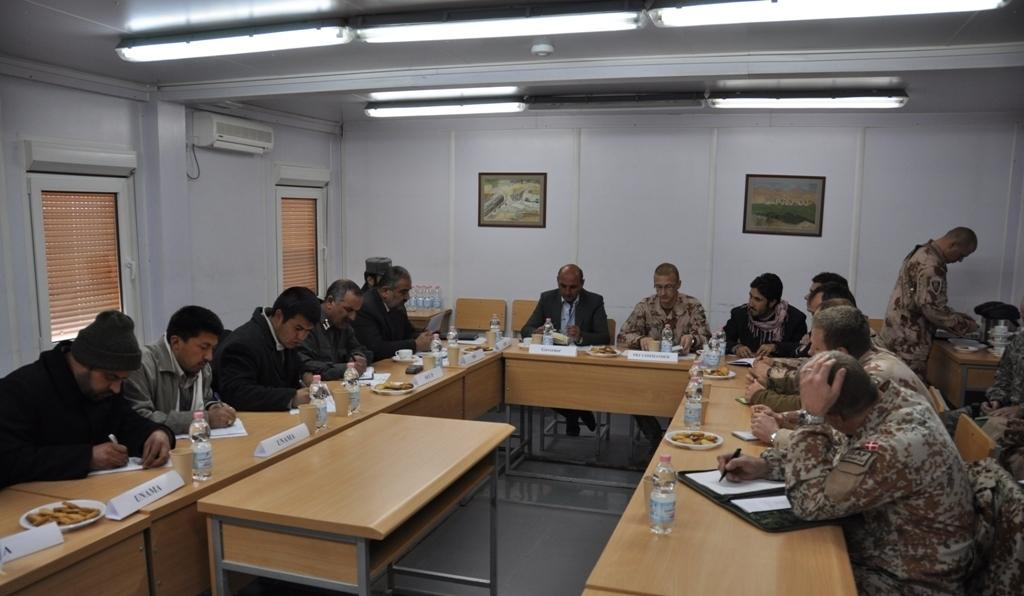What is happening in the image involving a group of men? The men are engaged in a discussion during a meeting. Where are the men located in the image? The men are sitting at a table in the image. What might be the purpose of the meeting? The purpose of the meeting is not explicitly stated in the image, but it can be inferred that the men are discussing something based on their body language and facial expressions. What type of blade is being used by the men during the meeting? There is no blade present in the image; the men are engaged in a discussion and not using any tools or instruments. 